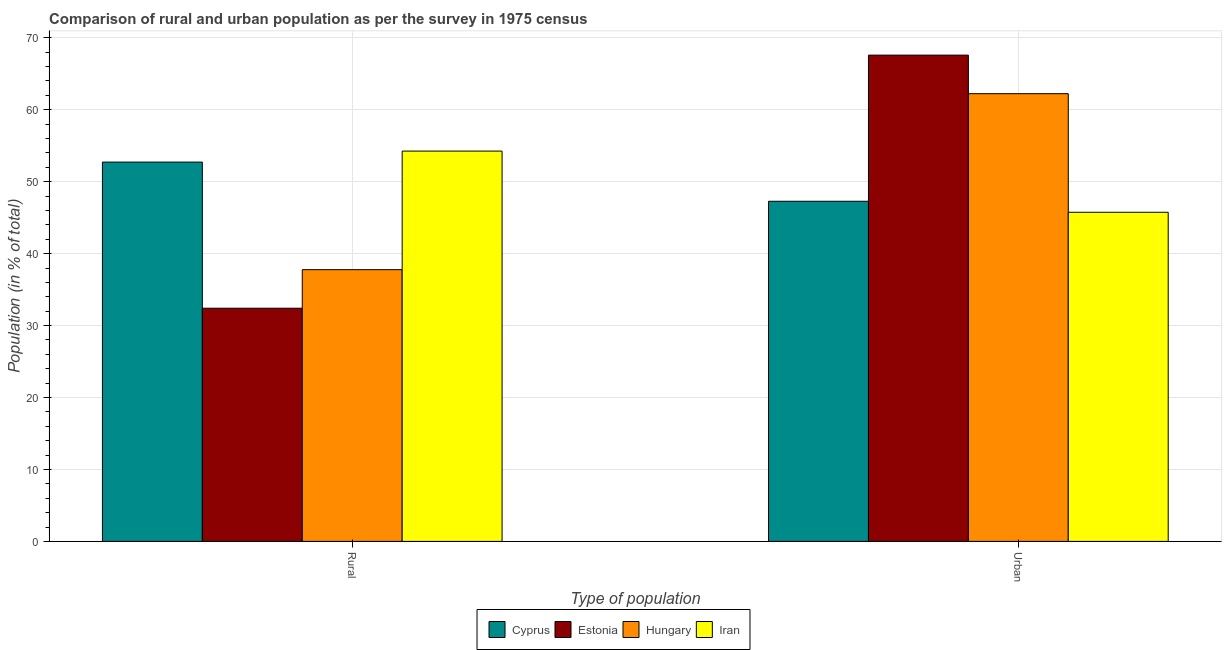How many groups of bars are there?
Your response must be concise. 2. Are the number of bars per tick equal to the number of legend labels?
Provide a short and direct response. Yes. Are the number of bars on each tick of the X-axis equal?
Give a very brief answer. Yes. How many bars are there on the 2nd tick from the left?
Offer a very short reply. 4. How many bars are there on the 1st tick from the right?
Your answer should be very brief. 4. What is the label of the 1st group of bars from the left?
Offer a terse response. Rural. What is the urban population in Hungary?
Your answer should be compact. 62.23. Across all countries, what is the maximum urban population?
Your answer should be very brief. 67.59. Across all countries, what is the minimum urban population?
Your response must be concise. 45.75. In which country was the urban population maximum?
Your response must be concise. Estonia. In which country was the urban population minimum?
Make the answer very short. Iran. What is the total urban population in the graph?
Ensure brevity in your answer.  222.84. What is the difference between the rural population in Iran and that in Hungary?
Offer a terse response. 16.48. What is the difference between the urban population in Estonia and the rural population in Cyprus?
Make the answer very short. 14.87. What is the average urban population per country?
Offer a terse response. 55.71. What is the difference between the rural population and urban population in Cyprus?
Provide a succinct answer. 5.45. In how many countries, is the urban population greater than 4 %?
Your answer should be compact. 4. What is the ratio of the urban population in Estonia to that in Iran?
Provide a short and direct response. 1.48. Is the urban population in Hungary less than that in Iran?
Offer a very short reply. No. In how many countries, is the rural population greater than the average rural population taken over all countries?
Your answer should be compact. 2. What does the 4th bar from the left in Rural represents?
Give a very brief answer. Iran. What does the 1st bar from the right in Urban represents?
Provide a succinct answer. Iran. Where does the legend appear in the graph?
Offer a terse response. Bottom center. How many legend labels are there?
Your answer should be compact. 4. How are the legend labels stacked?
Offer a very short reply. Horizontal. What is the title of the graph?
Make the answer very short. Comparison of rural and urban population as per the survey in 1975 census. What is the label or title of the X-axis?
Your response must be concise. Type of population. What is the label or title of the Y-axis?
Your answer should be very brief. Population (in % of total). What is the Population (in % of total) of Cyprus in Rural?
Your response must be concise. 52.72. What is the Population (in % of total) in Estonia in Rural?
Provide a succinct answer. 32.41. What is the Population (in % of total) in Hungary in Rural?
Keep it short and to the point. 37.77. What is the Population (in % of total) in Iran in Rural?
Provide a short and direct response. 54.25. What is the Population (in % of total) in Cyprus in Urban?
Your answer should be very brief. 47.28. What is the Population (in % of total) of Estonia in Urban?
Your response must be concise. 67.59. What is the Population (in % of total) in Hungary in Urban?
Give a very brief answer. 62.23. What is the Population (in % of total) of Iran in Urban?
Ensure brevity in your answer.  45.75. Across all Type of population, what is the maximum Population (in % of total) in Cyprus?
Ensure brevity in your answer.  52.72. Across all Type of population, what is the maximum Population (in % of total) in Estonia?
Provide a succinct answer. 67.59. Across all Type of population, what is the maximum Population (in % of total) in Hungary?
Make the answer very short. 62.23. Across all Type of population, what is the maximum Population (in % of total) of Iran?
Your answer should be very brief. 54.25. Across all Type of population, what is the minimum Population (in % of total) in Cyprus?
Provide a short and direct response. 47.28. Across all Type of population, what is the minimum Population (in % of total) of Estonia?
Your answer should be very brief. 32.41. Across all Type of population, what is the minimum Population (in % of total) in Hungary?
Your answer should be very brief. 37.77. Across all Type of population, what is the minimum Population (in % of total) in Iran?
Your answer should be compact. 45.75. What is the total Population (in % of total) of Hungary in the graph?
Provide a short and direct response. 100. What is the total Population (in % of total) in Iran in the graph?
Give a very brief answer. 100. What is the difference between the Population (in % of total) in Cyprus in Rural and that in Urban?
Make the answer very short. 5.45. What is the difference between the Population (in % of total) in Estonia in Rural and that in Urban?
Offer a very short reply. -35.18. What is the difference between the Population (in % of total) of Hungary in Rural and that in Urban?
Keep it short and to the point. -24.46. What is the difference between the Population (in % of total) in Iran in Rural and that in Urban?
Keep it short and to the point. 8.51. What is the difference between the Population (in % of total) in Cyprus in Rural and the Population (in % of total) in Estonia in Urban?
Ensure brevity in your answer.  -14.87. What is the difference between the Population (in % of total) of Cyprus in Rural and the Population (in % of total) of Hungary in Urban?
Your answer should be compact. -9.51. What is the difference between the Population (in % of total) of Cyprus in Rural and the Population (in % of total) of Iran in Urban?
Offer a terse response. 6.98. What is the difference between the Population (in % of total) in Estonia in Rural and the Population (in % of total) in Hungary in Urban?
Your response must be concise. -29.82. What is the difference between the Population (in % of total) of Estonia in Rural and the Population (in % of total) of Iran in Urban?
Offer a very short reply. -13.34. What is the difference between the Population (in % of total) of Hungary in Rural and the Population (in % of total) of Iran in Urban?
Your answer should be very brief. -7.98. What is the average Population (in % of total) of Cyprus per Type of population?
Provide a short and direct response. 50. What is the difference between the Population (in % of total) in Cyprus and Population (in % of total) in Estonia in Rural?
Give a very brief answer. 20.31. What is the difference between the Population (in % of total) in Cyprus and Population (in % of total) in Hungary in Rural?
Your response must be concise. 14.95. What is the difference between the Population (in % of total) in Cyprus and Population (in % of total) in Iran in Rural?
Ensure brevity in your answer.  -1.53. What is the difference between the Population (in % of total) in Estonia and Population (in % of total) in Hungary in Rural?
Provide a short and direct response. -5.36. What is the difference between the Population (in % of total) of Estonia and Population (in % of total) of Iran in Rural?
Keep it short and to the point. -21.84. What is the difference between the Population (in % of total) in Hungary and Population (in % of total) in Iran in Rural?
Keep it short and to the point. -16.48. What is the difference between the Population (in % of total) in Cyprus and Population (in % of total) in Estonia in Urban?
Your response must be concise. -20.31. What is the difference between the Population (in % of total) in Cyprus and Population (in % of total) in Hungary in Urban?
Give a very brief answer. -14.95. What is the difference between the Population (in % of total) in Cyprus and Population (in % of total) in Iran in Urban?
Offer a terse response. 1.53. What is the difference between the Population (in % of total) of Estonia and Population (in % of total) of Hungary in Urban?
Provide a short and direct response. 5.36. What is the difference between the Population (in % of total) in Estonia and Population (in % of total) in Iran in Urban?
Provide a short and direct response. 21.84. What is the difference between the Population (in % of total) of Hungary and Population (in % of total) of Iran in Urban?
Your answer should be very brief. 16.48. What is the ratio of the Population (in % of total) of Cyprus in Rural to that in Urban?
Ensure brevity in your answer.  1.12. What is the ratio of the Population (in % of total) in Estonia in Rural to that in Urban?
Give a very brief answer. 0.48. What is the ratio of the Population (in % of total) in Hungary in Rural to that in Urban?
Your answer should be very brief. 0.61. What is the ratio of the Population (in % of total) in Iran in Rural to that in Urban?
Offer a terse response. 1.19. What is the difference between the highest and the second highest Population (in % of total) in Cyprus?
Keep it short and to the point. 5.45. What is the difference between the highest and the second highest Population (in % of total) in Estonia?
Offer a very short reply. 35.18. What is the difference between the highest and the second highest Population (in % of total) in Hungary?
Make the answer very short. 24.46. What is the difference between the highest and the second highest Population (in % of total) of Iran?
Your answer should be very brief. 8.51. What is the difference between the highest and the lowest Population (in % of total) of Cyprus?
Offer a terse response. 5.45. What is the difference between the highest and the lowest Population (in % of total) of Estonia?
Give a very brief answer. 35.18. What is the difference between the highest and the lowest Population (in % of total) of Hungary?
Provide a succinct answer. 24.46. What is the difference between the highest and the lowest Population (in % of total) in Iran?
Give a very brief answer. 8.51. 